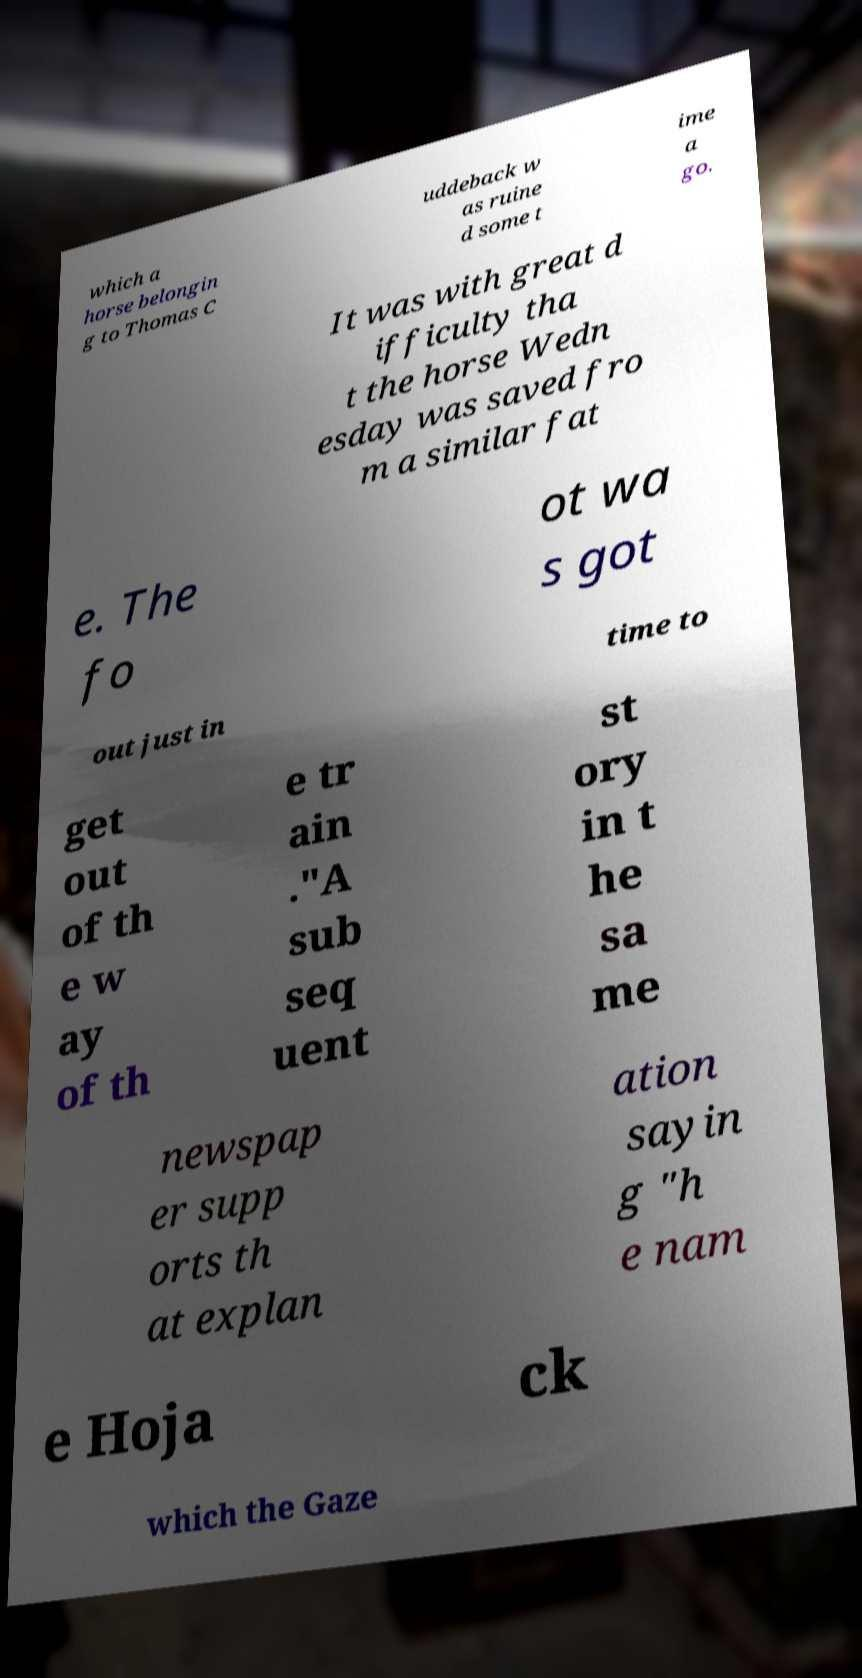There's text embedded in this image that I need extracted. Can you transcribe it verbatim? which a horse belongin g to Thomas C uddeback w as ruine d some t ime a go. It was with great d ifficulty tha t the horse Wedn esday was saved fro m a similar fat e. The fo ot wa s got out just in time to get out of th e w ay of th e tr ain ."A sub seq uent st ory in t he sa me newspap er supp orts th at explan ation sayin g "h e nam e Hoja ck which the Gaze 